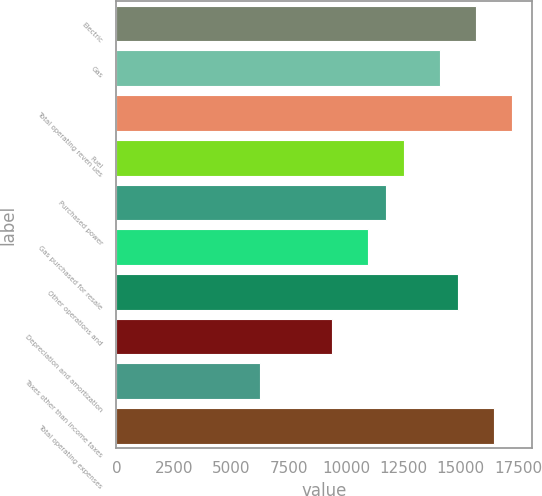Convert chart to OTSL. <chart><loc_0><loc_0><loc_500><loc_500><bar_chart><fcel>Electric<fcel>Gas<fcel>Total operating reven ues<fcel>Fuel<fcel>Purchased power<fcel>Gas purchased for resale<fcel>Other operations and<fcel>Depreciation and amortization<fcel>Taxes other than income taxes<fcel>Total operating expenses<nl><fcel>15675.5<fcel>14108.2<fcel>17242.8<fcel>12540.9<fcel>11757.3<fcel>10973.6<fcel>14891.9<fcel>9406.34<fcel>6271.74<fcel>16459.2<nl></chart> 